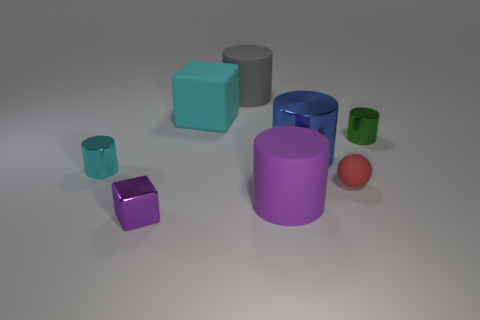How many objects are there in the image, and can you describe their colors? There are seven objects in the image including a teal cube, a grey cylinder, a blue cylinder, a small green cup, a tiny green cylinder, a purple cube, and a red sphere. Their colors range from vibrant to more muted tones. Which color appears the most and which appears the least? The color that appears the most is green, present on two objects (the small cup and the tiny cylinder). The red color appears the least, with just one red sphere in the image. 